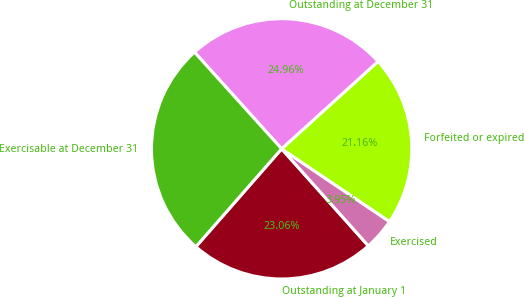Convert chart. <chart><loc_0><loc_0><loc_500><loc_500><pie_chart><fcel>Outstanding at January 1<fcel>Exercised<fcel>Forfeited or expired<fcel>Outstanding at December 31<fcel>Exercisable at December 31<nl><fcel>23.06%<fcel>3.95%<fcel>21.16%<fcel>24.96%<fcel>26.87%<nl></chart> 